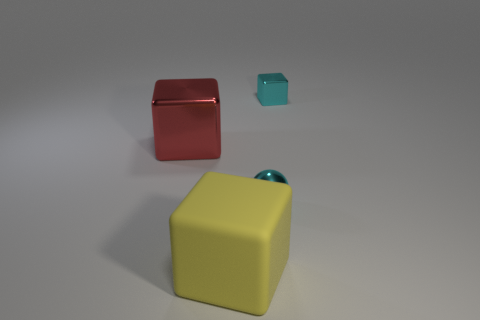Add 2 small cyan spheres. How many objects exist? 6 Subtract all cubes. How many objects are left? 1 Subtract all big metallic things. Subtract all cyan objects. How many objects are left? 1 Add 4 big red shiny blocks. How many big red shiny blocks are left? 5 Add 1 red objects. How many red objects exist? 2 Subtract 0 green cylinders. How many objects are left? 4 